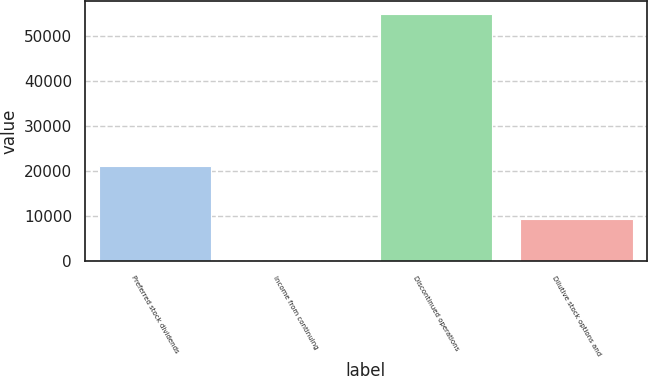<chart> <loc_0><loc_0><loc_500><loc_500><bar_chart><fcel>Preferred stock dividends<fcel>Income from continuing<fcel>Discontinued operations<fcel>Dilutive stock options and<nl><fcel>21130<fcel>0.71<fcel>54893<fcel>9302.34<nl></chart> 